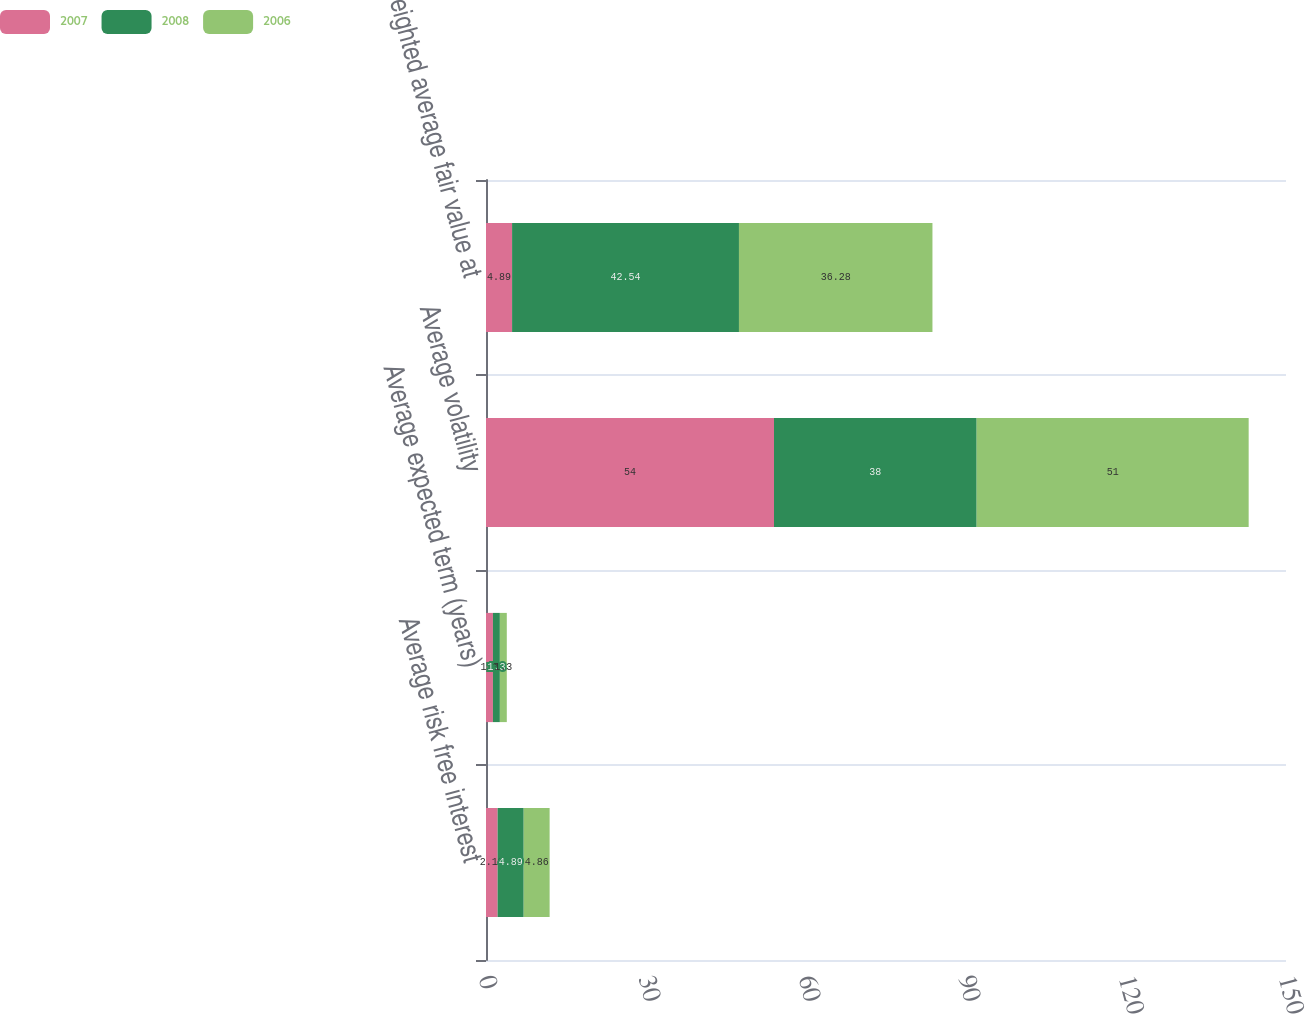Convert chart to OTSL. <chart><loc_0><loc_0><loc_500><loc_500><stacked_bar_chart><ecel><fcel>Average risk free interest<fcel>Average expected term (years)<fcel>Average volatility<fcel>Weighted average fair value at<nl><fcel>2007<fcel>2.18<fcel>1.3<fcel>54<fcel>4.89<nl><fcel>2008<fcel>4.89<fcel>1.3<fcel>38<fcel>42.54<nl><fcel>2006<fcel>4.86<fcel>1.3<fcel>51<fcel>36.28<nl></chart> 